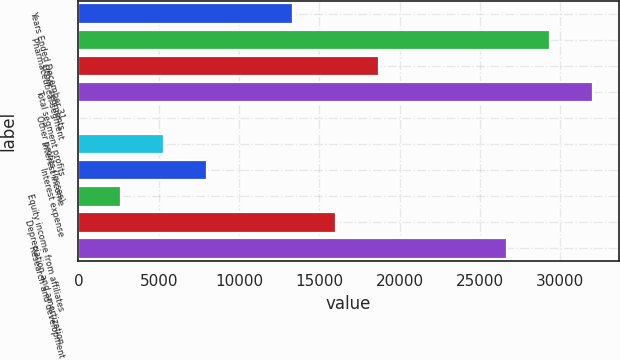<chart> <loc_0><loc_0><loc_500><loc_500><bar_chart><fcel>Years Ended December 31<fcel>Pharmaceutical segment<fcel>Other segments<fcel>Total segment profits<fcel>Other profits (losses)<fcel>Interest income<fcel>Interest expense<fcel>Equity income from affiliates<fcel>Depreciation and amortization<fcel>Research and development<nl><fcel>13360.5<fcel>29383.5<fcel>18701.5<fcel>32054<fcel>8<fcel>5349<fcel>8019.5<fcel>2678.5<fcel>16031<fcel>26713<nl></chart> 